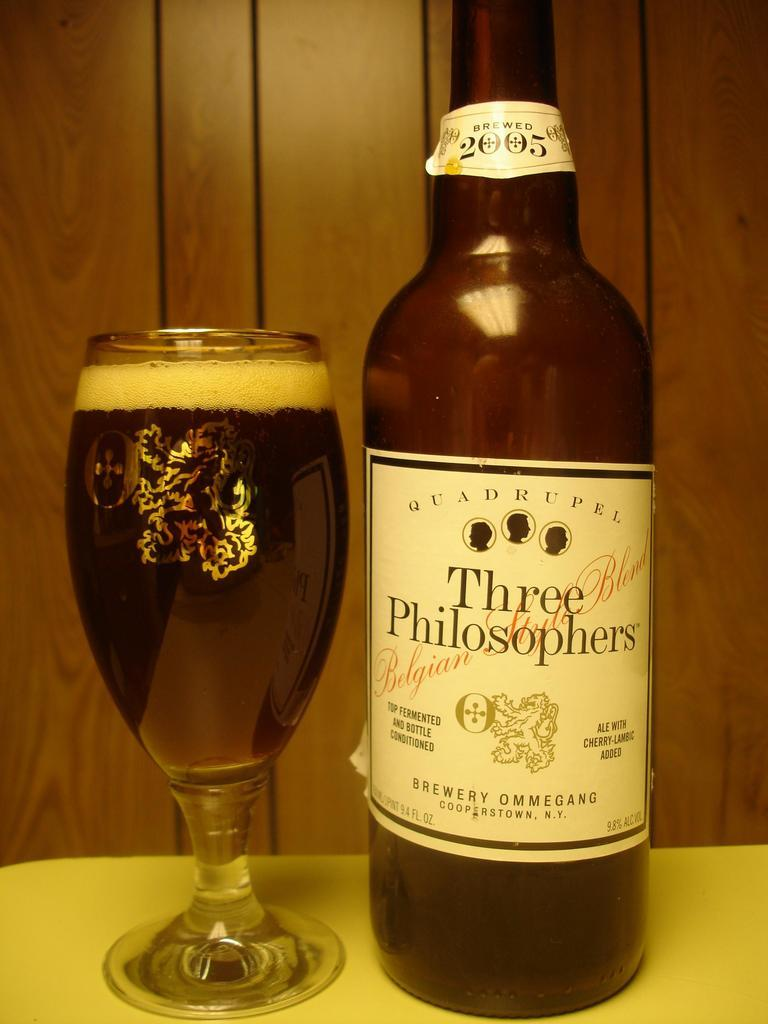<image>
Relay a brief, clear account of the picture shown. A bottle of Three Philosophers beer was brewed up Jamestown New York. 